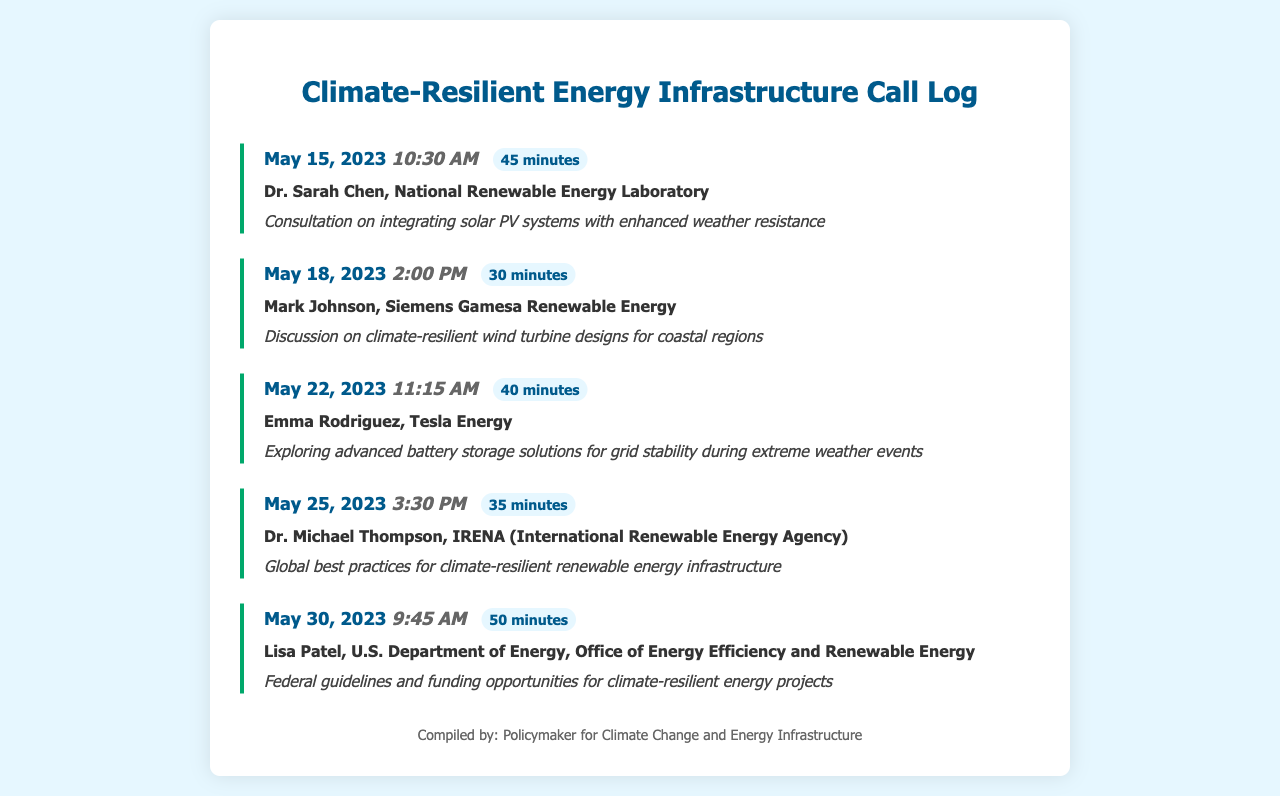What is the date of the first consultation? The first consultation is recorded on May 15, 2023.
Answer: May 15, 2023 Who did Dr. Sarah Chen work for? Dr. Sarah Chen is affiliated with the National Renewable Energy Laboratory.
Answer: National Renewable Energy Laboratory What was the topic of the call on May 22, 2023? The call on May 22, 2023, focused on advanced battery storage solutions for grid stability.
Answer: Advanced battery storage solutions for grid stability during extreme weather events How long was the consultation with Mark Johnson? The consultation with Mark Johnson lasted 30 minutes.
Answer: 30 minutes What is the main subject discussed on May 30, 2023? The main subject discussed was federal guidelines and funding opportunities for climate-resilient energy projects.
Answer: Federal guidelines and funding opportunities for climate-resilient energy projects Which expert discussed wind turbine designs? Mark Johnson discussed climate-resilient wind turbine designs for coastal regions.
Answer: Mark Johnson How many total consultations are listed in the log? There are a total of five consultations listed in the log.
Answer: Five What is the call duration for the last consultation? The call duration for the last consultation is 50 minutes.
Answer: 50 minutes What organization is associated with Lisa Patel? Lisa Patel is associated with the U.S. Department of Energy, Office of Energy Efficiency and Renewable Energy.
Answer: U.S. Department of Energy, Office of Energy Efficiency and Renewable Energy 